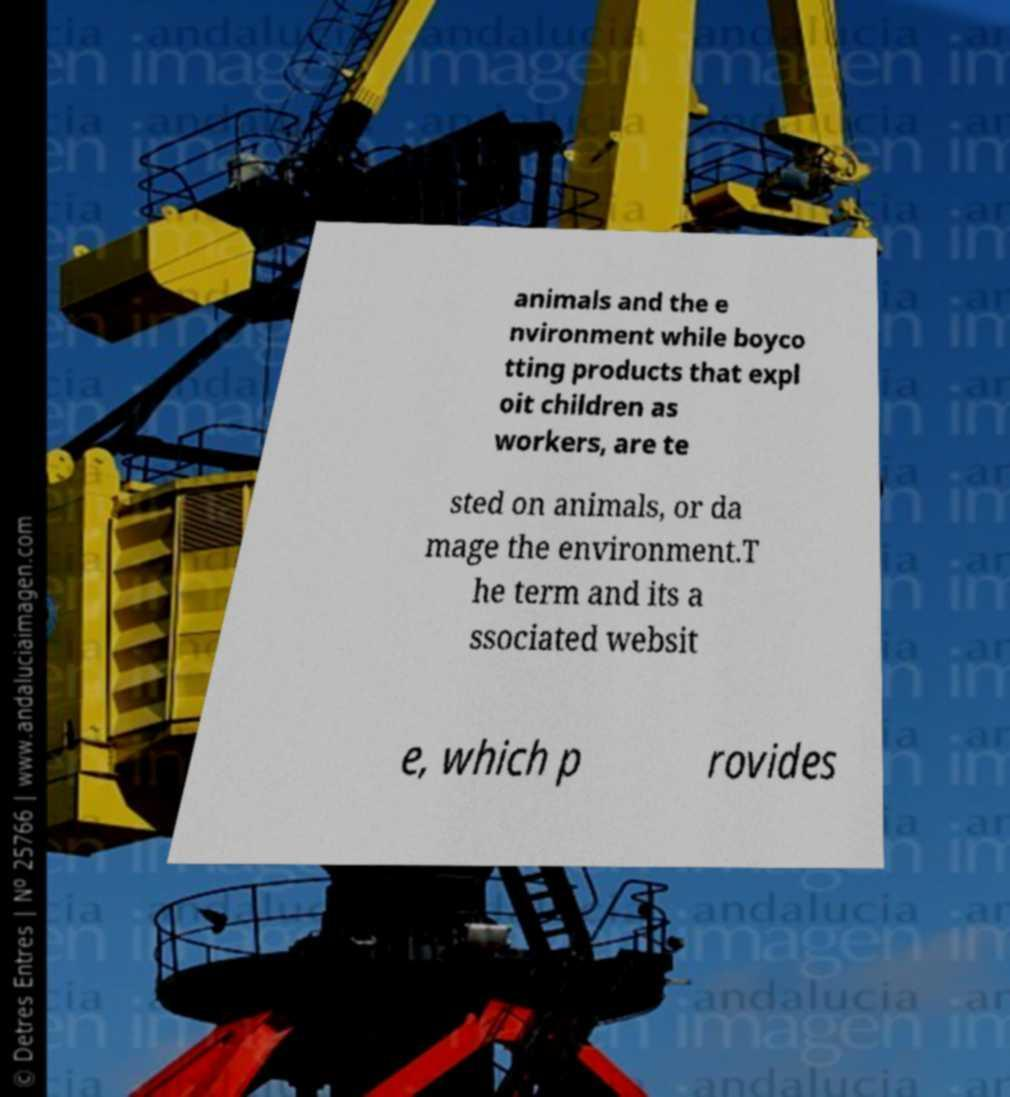I need the written content from this picture converted into text. Can you do that? animals and the e nvironment while boyco tting products that expl oit children as workers, are te sted on animals, or da mage the environment.T he term and its a ssociated websit e, which p rovides 